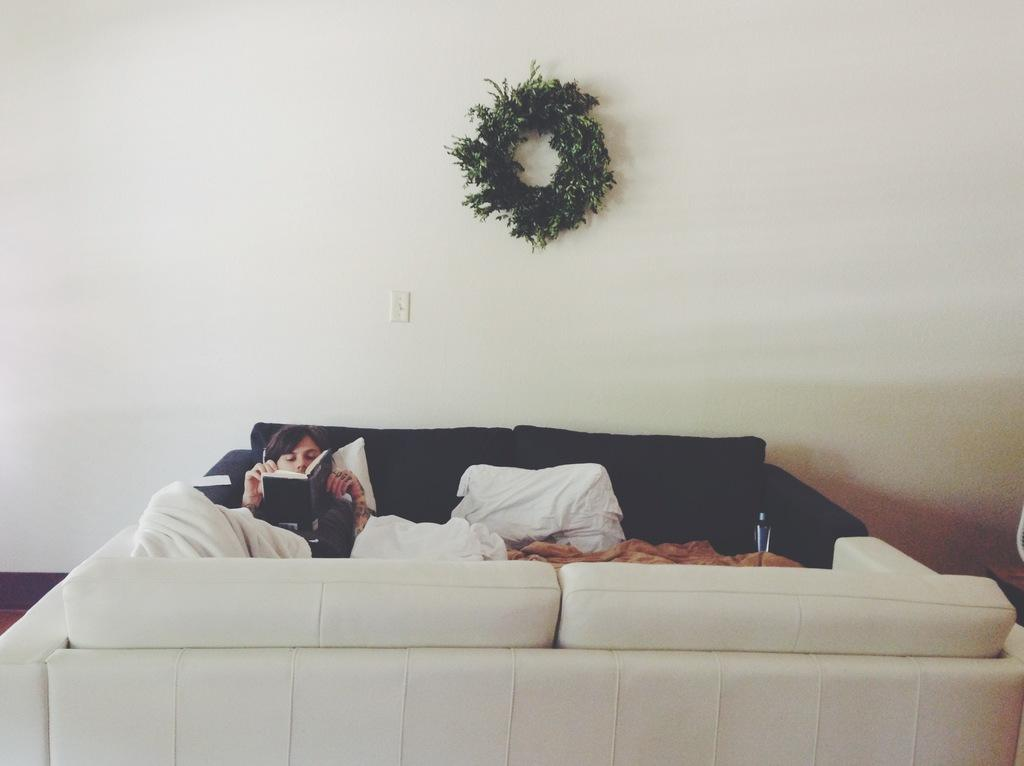What is the person in the image doing? The person is lying on a bed and reading a book. What can be seen in the background of the image? There is a wall and a decorative plant in the background. What type of leaf is being used as a bookmark in the image? There is no leaf visible in the image, and the person is not using a leaf as a bookmark. 